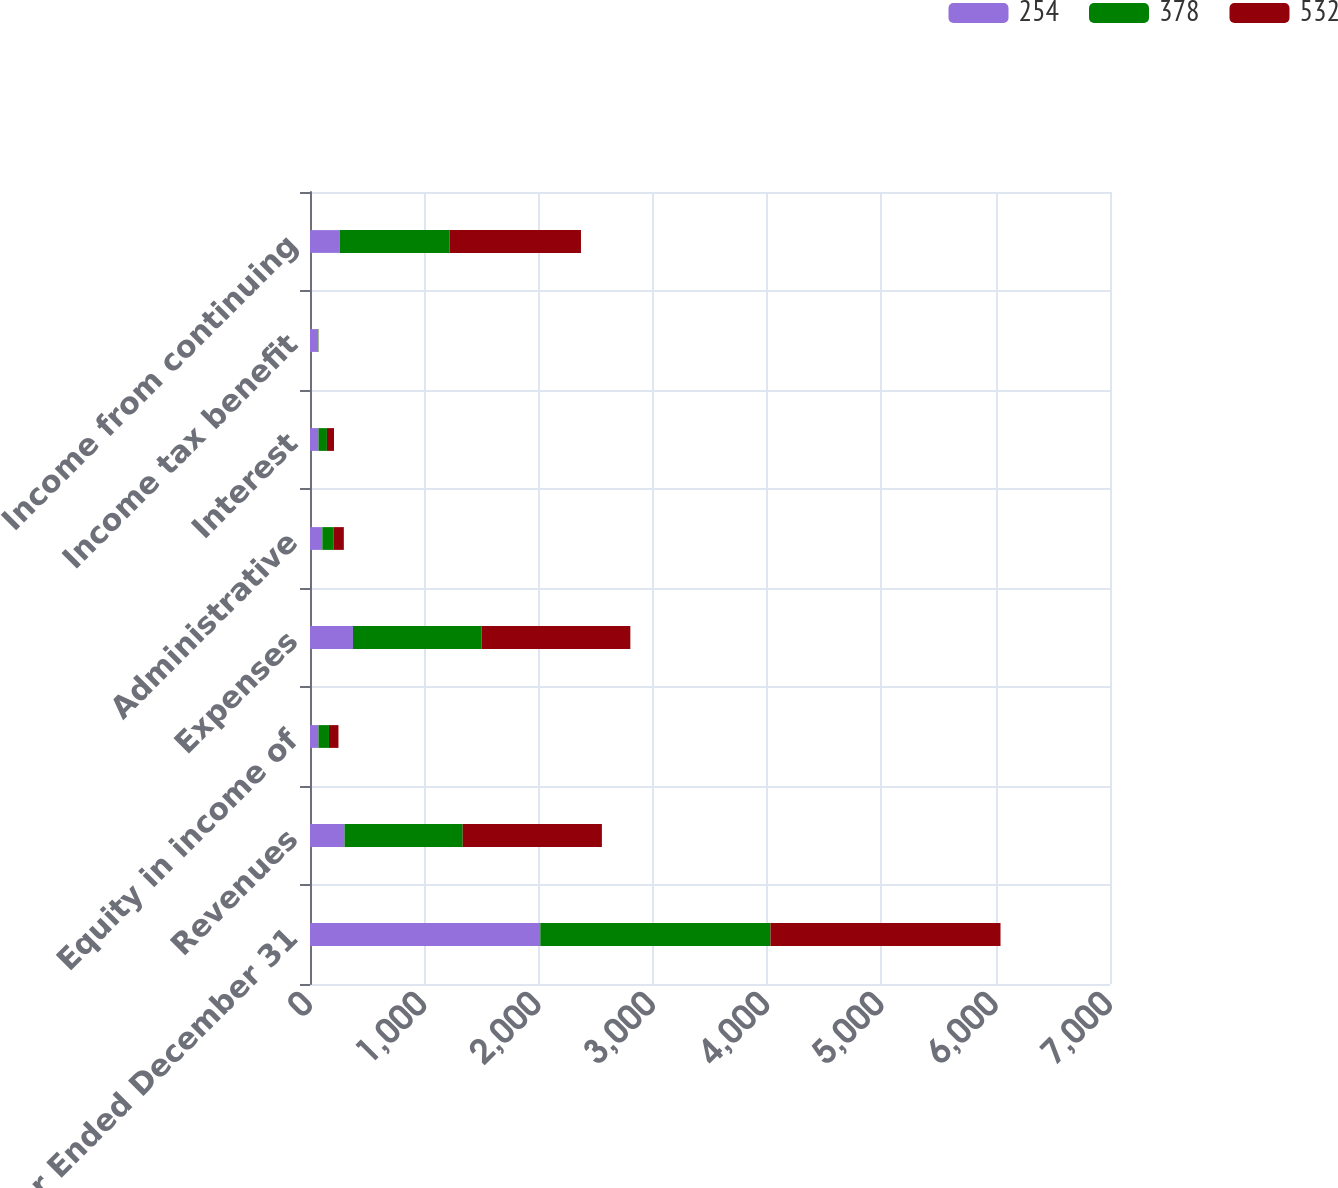Convert chart. <chart><loc_0><loc_0><loc_500><loc_500><stacked_bar_chart><ecel><fcel>Year Ended December 31<fcel>Revenues<fcel>Equity in income of<fcel>Expenses<fcel>Administrative<fcel>Interest<fcel>Income tax benefit<fcel>Income from continuing<nl><fcel>254<fcel>2015<fcel>302<fcel>74<fcel>376<fcel>108<fcel>74<fcel>66<fcel>260<nl><fcel>378<fcel>2014<fcel>1034<fcel>92<fcel>1126<fcel>97<fcel>74<fcel>7<fcel>962<nl><fcel>532<fcel>2013<fcel>1218<fcel>83<fcel>1301<fcel>91<fcel>62<fcel>1<fcel>1149<nl></chart> 